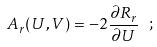Convert formula to latex. <formula><loc_0><loc_0><loc_500><loc_500>A _ { r } ( U , V ) = - 2 \frac { \partial R _ { r } } { \partial U } \ ;</formula> 